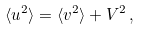<formula> <loc_0><loc_0><loc_500><loc_500>\langle u ^ { 2 } \rangle = \langle v ^ { 2 } \rangle + V ^ { 2 } \, ,</formula> 